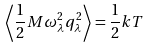Convert formula to latex. <formula><loc_0><loc_0><loc_500><loc_500>\left \langle \frac { 1 } { 2 } M \omega _ { \lambda } ^ { 2 } q _ { \lambda } ^ { 2 } \right \rangle = \frac { 1 } { 2 } k T</formula> 